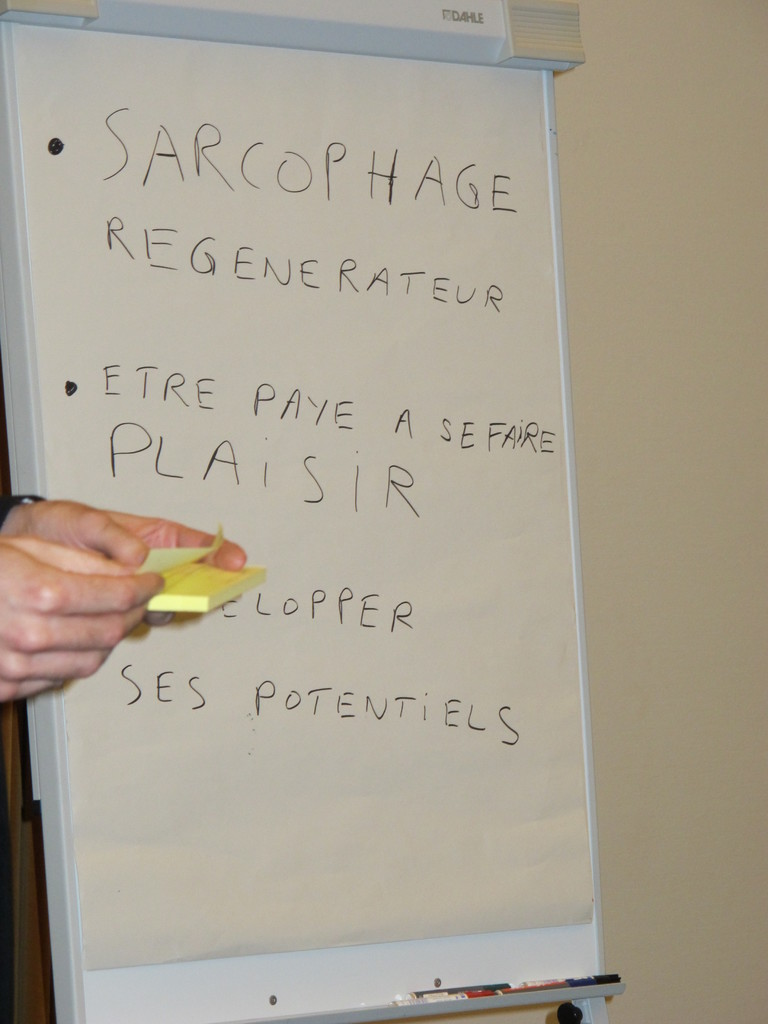Can you explore 'DEVELOPPER SES POTENTIELS' in the context of personal growth? 'DEVELOPPER SES POTENTIELS,' or 'Developing one's potentials,' likely reflects themes of self-improvement and maximizing individual capabilities. This discussion could revolve around educational programs, mentorship, self-driven learning, or corporate training initiatives aimed at personal and professional growth. 